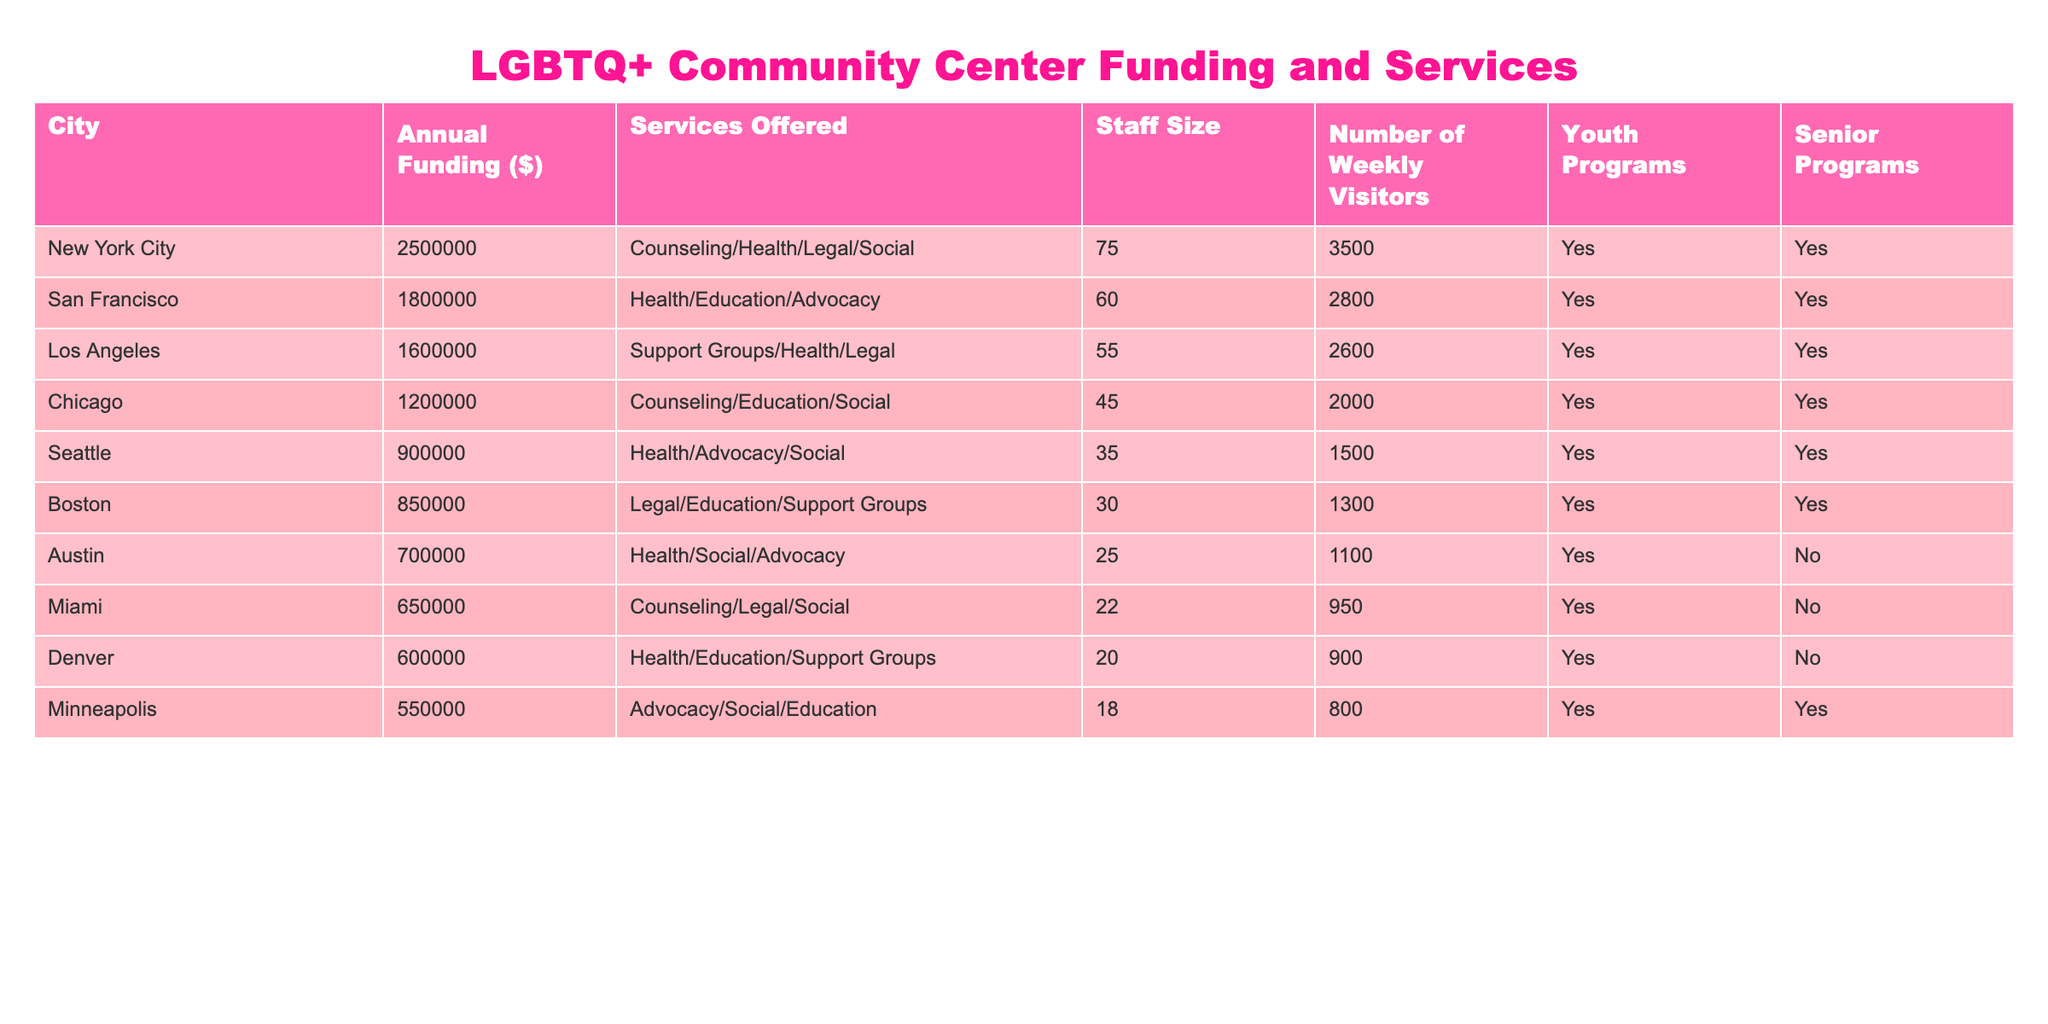What city has the highest annual funding for LGBTQ+ community centers? By looking at the "Annual Funding" column, we see that New York City has the highest value of 2,500,000.
Answer: New York City Which city offers the lowest number of weekly visitors to its LGBTQ+ community center? Reviewing the "Number of Weekly Visitors" column, Miami has the lowest value of 950.
Answer: Miami What is the total annual funding allocated for LGBTQ+ community centers in San Francisco and Los Angeles combined? Adding the annual funding for San Francisco (1,800,000) and Los Angeles (1,600,000) gives us a total of 3,400,000.
Answer: 3400000 Do all cities have youth programs available at their community centers? Checking the "Youth Programs" column, we find that Austin and Miami do not offer youth programs, so the answer is no.
Answer: No Which city employs the most staff at its LGBTQ+ community center, and how many staff members are there? From the "Staff Size" column, New York City has the highest number of staff with 75 members.
Answer: New York City, 75 How does the annual funding for Chicago compare to that of Seattle? The annual funding for Chicago is 1,200,000 and for Seattle is 900,000. The difference is 1,200,000 - 900,000 = 300,000; thus, Chicago has more funding by this amount.
Answer: 300000 Which two cities provide services for seniors at their community centers? By examining the "Senior Programs" column, we can see that both New York City and San Francisco provide services for seniors, as indicated by "Yes" in their rows.
Answer: New York City and San Francisco What is the average number of weekly visitors across all the cities listed? Summing up the number of weekly visitors (3,500 + 2,800 + 2,600 + 2,000 + 1,500 + 1,300 + 1,100 + 950 + 900 + 800 = 17,450) and dividing by the total number of cities (10) yields an average of 1,745.
Answer: 1745 How many cities offer both youth and senior programs? Reviewing both the "Youth Programs" and "Senior Programs" columns, we see that New York City, San Francisco, Los Angeles, Chicago, Seattle, Boston, and Minneapolis provide both, totaling 7 cities.
Answer: 7 